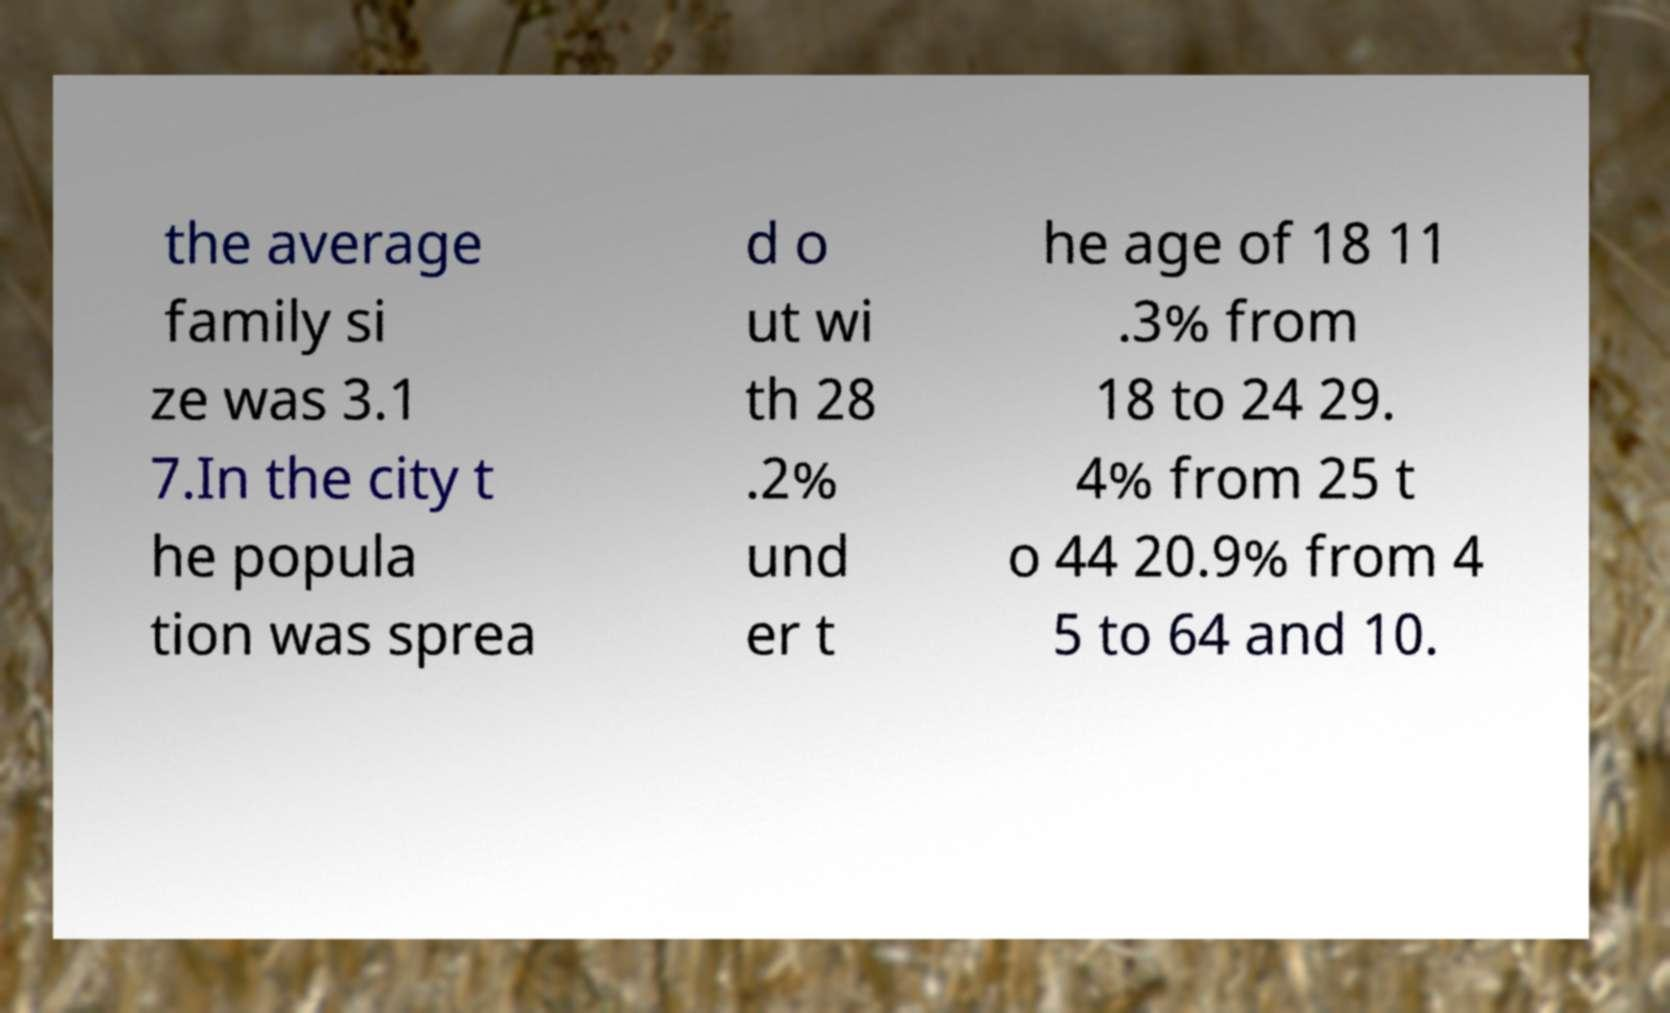Please read and relay the text visible in this image. What does it say? the average family si ze was 3.1 7.In the city t he popula tion was sprea d o ut wi th 28 .2% und er t he age of 18 11 .3% from 18 to 24 29. 4% from 25 t o 44 20.9% from 4 5 to 64 and 10. 